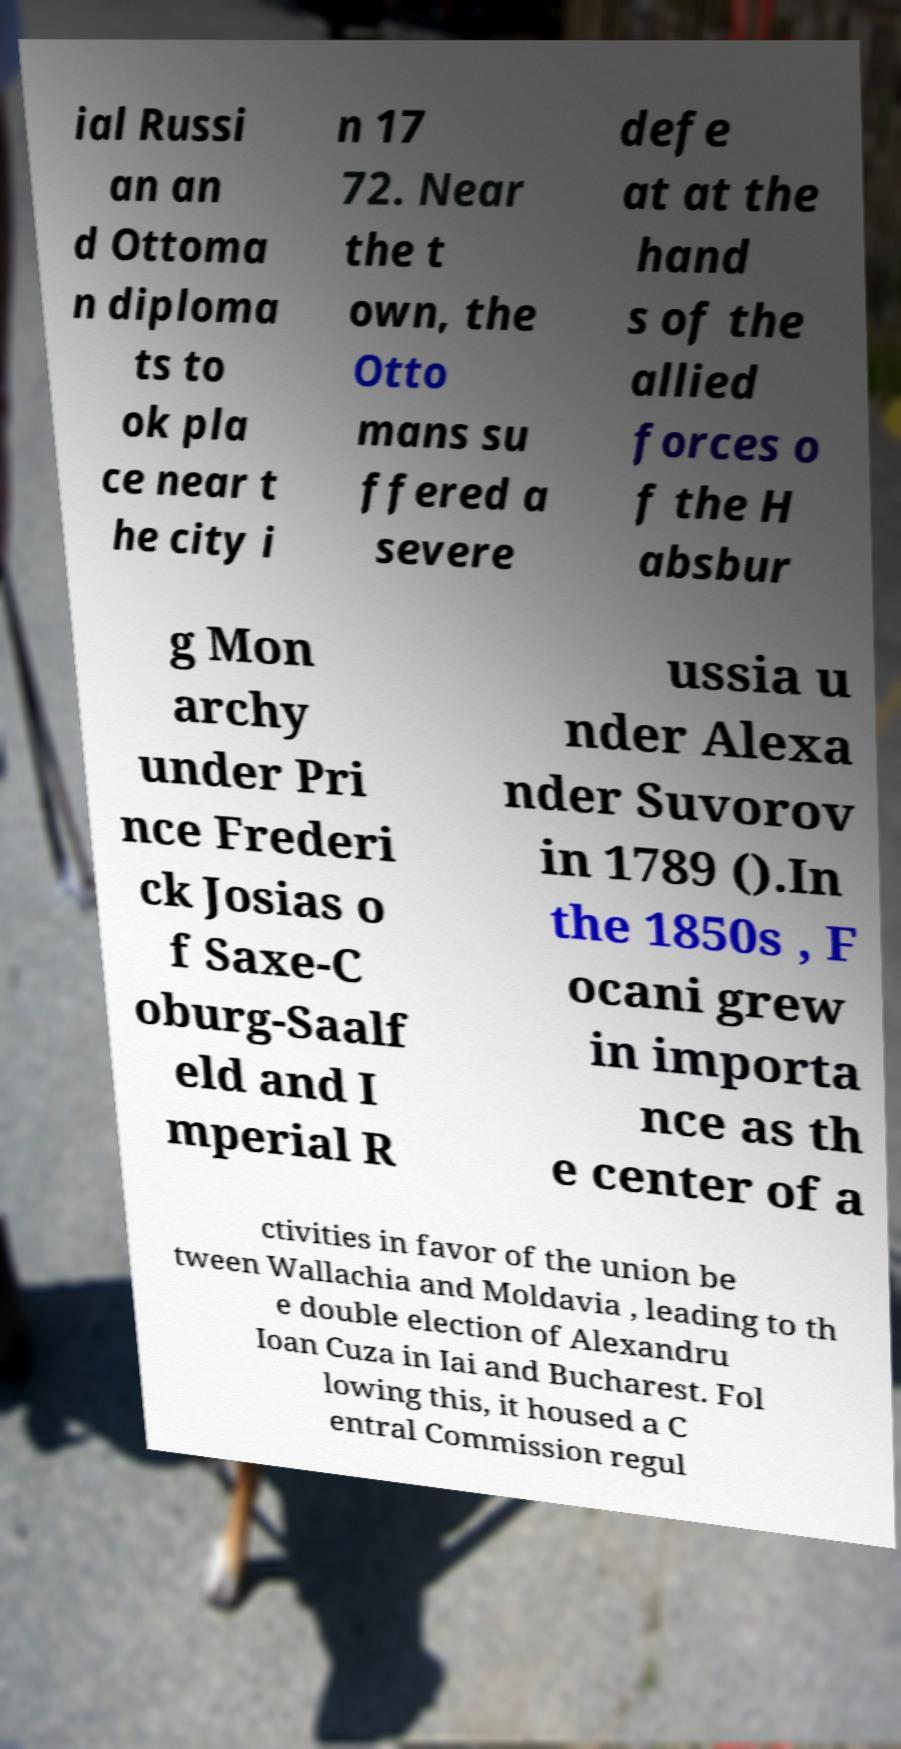Could you extract and type out the text from this image? ial Russi an an d Ottoma n diploma ts to ok pla ce near t he city i n 17 72. Near the t own, the Otto mans su ffered a severe defe at at the hand s of the allied forces o f the H absbur g Mon archy under Pri nce Frederi ck Josias o f Saxe-C oburg-Saalf eld and I mperial R ussia u nder Alexa nder Suvorov in 1789 ().In the 1850s , F ocani grew in importa nce as th e center of a ctivities in favor of the union be tween Wallachia and Moldavia , leading to th e double election of Alexandru Ioan Cuza in Iai and Bucharest. Fol lowing this, it housed a C entral Commission regul 